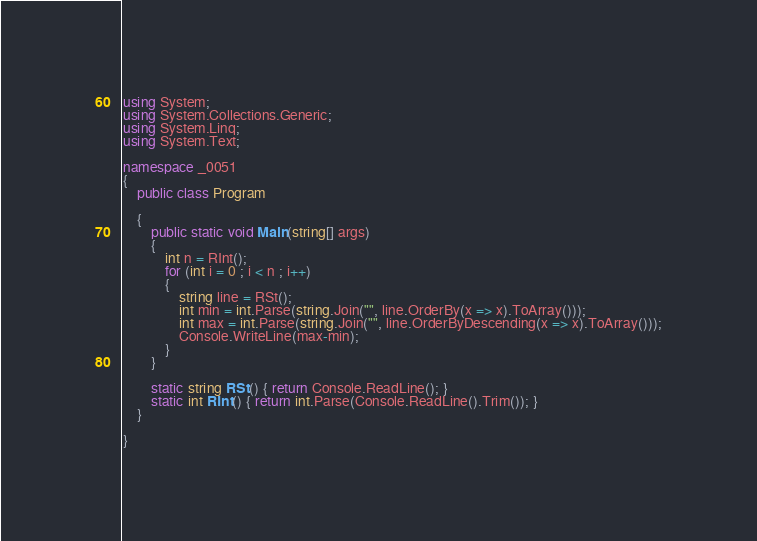Convert code to text. <code><loc_0><loc_0><loc_500><loc_500><_C#_>using System;
using System.Collections.Generic;
using System.Linq;
using System.Text;

namespace _0051
{
    public class Program

    {
        public static void Main(string[] args)
        {
            int n = RInt();
            for (int i = 0 ; i < n ; i++)
            {
                string line = RSt();
                int min = int.Parse(string.Join("", line.OrderBy(x => x).ToArray()));
                int max = int.Parse(string.Join("", line.OrderByDescending(x => x).ToArray()));
                Console.WriteLine(max-min);
            }       
        }

        static string RSt() { return Console.ReadLine(); }
        static int RInt() { return int.Parse(Console.ReadLine().Trim()); }
    }

}

</code> 